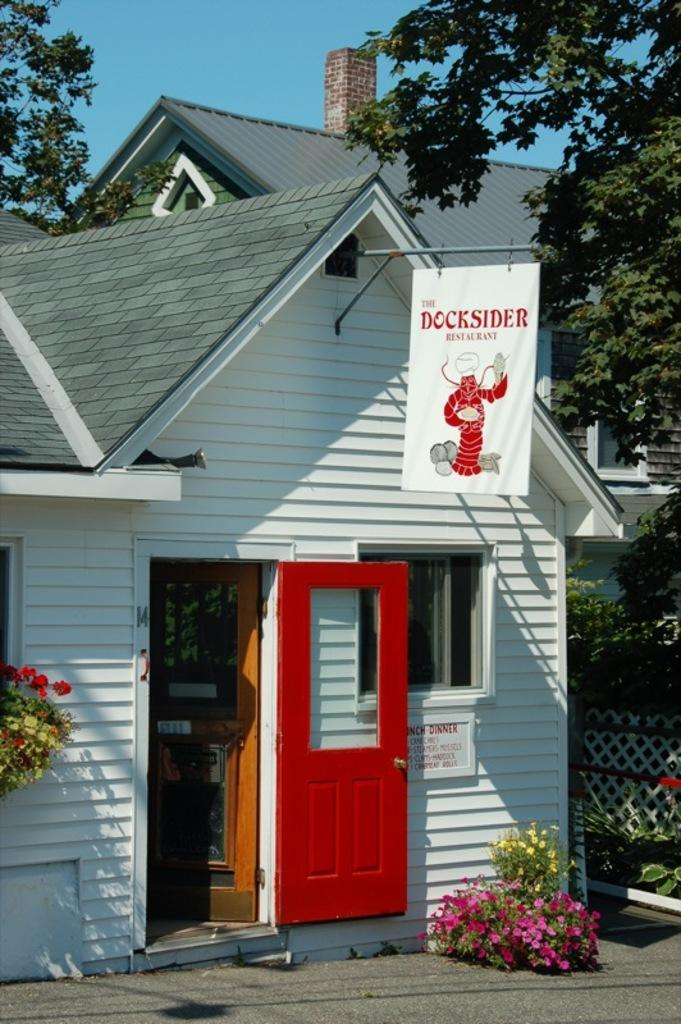What type of plants can be seen in the image? There are plants with flowers in the image. What architectural features are present in the image? There are doors and buildings in the image. What other objects can be seen in the image? There are boards and trees in the image. What is visible in the background of the image? The sky is visible in the image. What type of railway can be seen in the image? There is no railway present in the image. What emotion is the plant expressing in the image? Plants do not have emotions, so this question cannot be answered. 